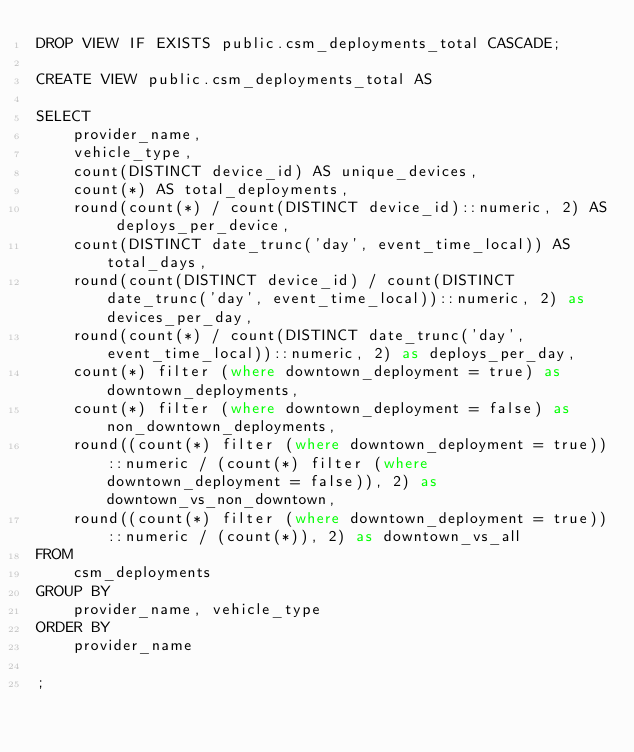<code> <loc_0><loc_0><loc_500><loc_500><_SQL_>DROP VIEW IF EXISTS public.csm_deployments_total CASCADE;

CREATE VIEW public.csm_deployments_total AS

SELECT
    provider_name,
    vehicle_type,
    count(DISTINCT device_id) AS unique_devices,
    count(*) AS total_deployments,
    round(count(*) / count(DISTINCT device_id)::numeric, 2) AS deploys_per_device,
    count(DISTINCT date_trunc('day', event_time_local)) AS total_days,
    round(count(DISTINCT device_id) / count(DISTINCT date_trunc('day', event_time_local))::numeric, 2) as devices_per_day,
    round(count(*) / count(DISTINCT date_trunc('day', event_time_local))::numeric, 2) as deploys_per_day,
    count(*) filter (where downtown_deployment = true) as downtown_deployments,
    count(*) filter (where downtown_deployment = false) as non_downtown_deployments,
    round((count(*) filter (where downtown_deployment = true))::numeric / (count(*) filter (where downtown_deployment = false)), 2) as downtown_vs_non_downtown,
    round((count(*) filter (where downtown_deployment = true))::numeric / (count(*)), 2) as downtown_vs_all
FROM
    csm_deployments
GROUP BY
    provider_name, vehicle_type
ORDER BY
    provider_name

;</code> 